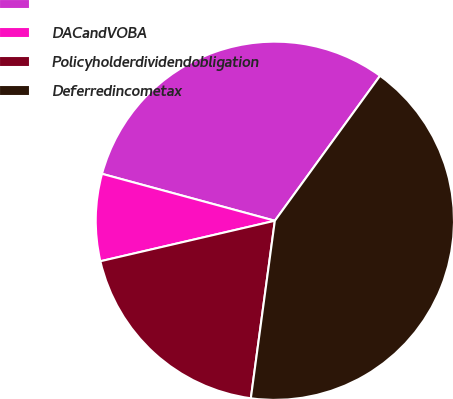<chart> <loc_0><loc_0><loc_500><loc_500><pie_chart><ecel><fcel>DACandVOBA<fcel>Policyholderdividendobligation<fcel>Deferredincometax<nl><fcel>30.77%<fcel>7.85%<fcel>19.23%<fcel>42.15%<nl></chart> 